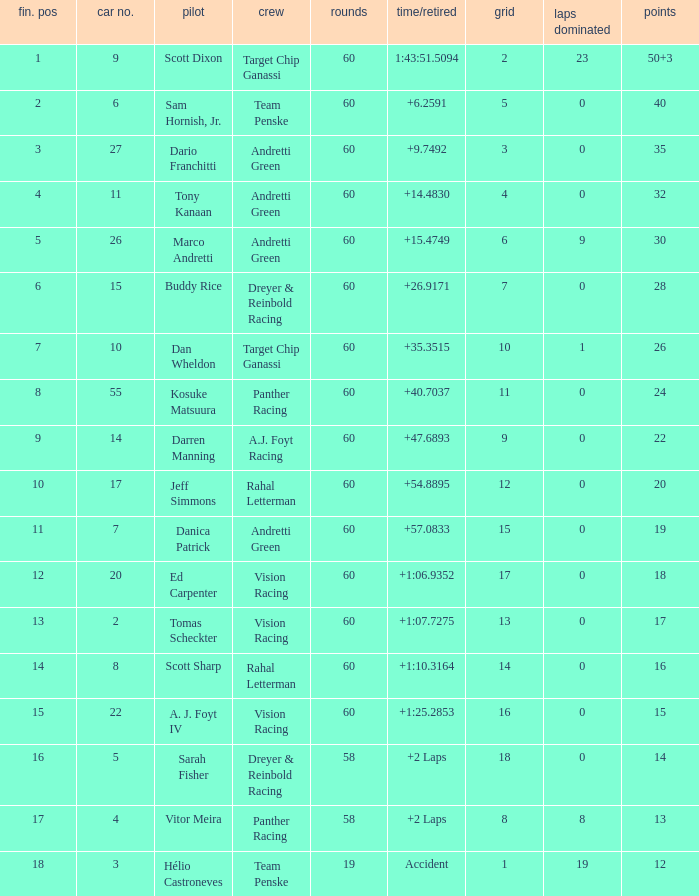Name the total number of grid for 30 1.0. 